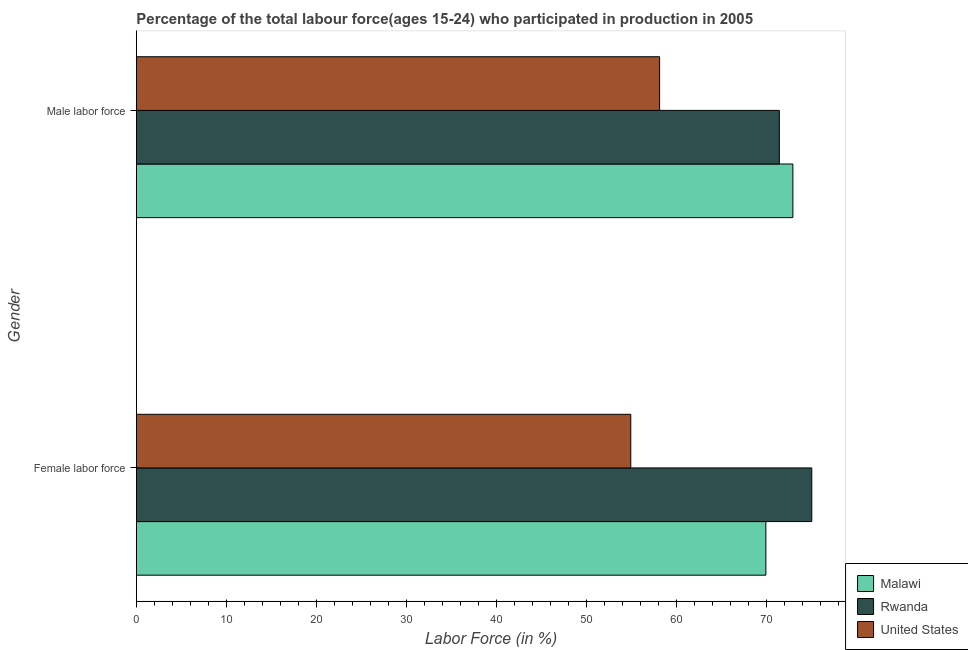How many different coloured bars are there?
Give a very brief answer. 3. How many groups of bars are there?
Offer a very short reply. 2. Are the number of bars on each tick of the Y-axis equal?
Make the answer very short. Yes. How many bars are there on the 2nd tick from the top?
Your answer should be compact. 3. What is the label of the 2nd group of bars from the top?
Your answer should be compact. Female labor force. What is the percentage of female labor force in United States?
Keep it short and to the point. 54.9. Across all countries, what is the minimum percentage of female labor force?
Your answer should be compact. 54.9. In which country was the percentage of female labor force maximum?
Your answer should be compact. Rwanda. In which country was the percentage of male labour force minimum?
Offer a terse response. United States. What is the total percentage of male labour force in the graph?
Your response must be concise. 202.4. What is the difference between the percentage of female labor force in United States and that in Malawi?
Your response must be concise. -15. What is the difference between the percentage of female labor force in Rwanda and the percentage of male labour force in Malawi?
Make the answer very short. 2.1. What is the average percentage of female labor force per country?
Your answer should be very brief. 66.6. What is the difference between the percentage of female labor force and percentage of male labour force in United States?
Your response must be concise. -3.2. In how many countries, is the percentage of male labour force greater than 48 %?
Keep it short and to the point. 3. What is the ratio of the percentage of male labour force in United States to that in Malawi?
Your response must be concise. 0.8. What does the 1st bar from the bottom in Female labor force represents?
Offer a very short reply. Malawi. How many bars are there?
Your response must be concise. 6. Are all the bars in the graph horizontal?
Provide a short and direct response. Yes. Does the graph contain any zero values?
Your answer should be very brief. No. How many legend labels are there?
Provide a short and direct response. 3. How are the legend labels stacked?
Make the answer very short. Vertical. What is the title of the graph?
Provide a short and direct response. Percentage of the total labour force(ages 15-24) who participated in production in 2005. What is the label or title of the X-axis?
Make the answer very short. Labor Force (in %). What is the label or title of the Y-axis?
Make the answer very short. Gender. What is the Labor Force (in %) of Malawi in Female labor force?
Offer a terse response. 69.9. What is the Labor Force (in %) of United States in Female labor force?
Give a very brief answer. 54.9. What is the Labor Force (in %) in Malawi in Male labor force?
Provide a succinct answer. 72.9. What is the Labor Force (in %) of Rwanda in Male labor force?
Offer a very short reply. 71.4. What is the Labor Force (in %) of United States in Male labor force?
Your response must be concise. 58.1. Across all Gender, what is the maximum Labor Force (in %) in Malawi?
Ensure brevity in your answer.  72.9. Across all Gender, what is the maximum Labor Force (in %) of United States?
Ensure brevity in your answer.  58.1. Across all Gender, what is the minimum Labor Force (in %) in Malawi?
Your answer should be very brief. 69.9. Across all Gender, what is the minimum Labor Force (in %) in Rwanda?
Offer a terse response. 71.4. Across all Gender, what is the minimum Labor Force (in %) in United States?
Provide a short and direct response. 54.9. What is the total Labor Force (in %) of Malawi in the graph?
Your answer should be very brief. 142.8. What is the total Labor Force (in %) of Rwanda in the graph?
Keep it short and to the point. 146.4. What is the total Labor Force (in %) of United States in the graph?
Provide a succinct answer. 113. What is the difference between the Labor Force (in %) in United States in Female labor force and that in Male labor force?
Offer a terse response. -3.2. What is the difference between the Labor Force (in %) in Rwanda in Female labor force and the Labor Force (in %) in United States in Male labor force?
Your answer should be very brief. 16.9. What is the average Labor Force (in %) of Malawi per Gender?
Provide a short and direct response. 71.4. What is the average Labor Force (in %) in Rwanda per Gender?
Your answer should be very brief. 73.2. What is the average Labor Force (in %) in United States per Gender?
Provide a succinct answer. 56.5. What is the difference between the Labor Force (in %) in Malawi and Labor Force (in %) in United States in Female labor force?
Make the answer very short. 15. What is the difference between the Labor Force (in %) of Rwanda and Labor Force (in %) of United States in Female labor force?
Your answer should be very brief. 20.1. What is the difference between the Labor Force (in %) of Malawi and Labor Force (in %) of Rwanda in Male labor force?
Provide a succinct answer. 1.5. What is the difference between the Labor Force (in %) in Malawi and Labor Force (in %) in United States in Male labor force?
Keep it short and to the point. 14.8. What is the difference between the Labor Force (in %) in Rwanda and Labor Force (in %) in United States in Male labor force?
Give a very brief answer. 13.3. What is the ratio of the Labor Force (in %) of Malawi in Female labor force to that in Male labor force?
Make the answer very short. 0.96. What is the ratio of the Labor Force (in %) of Rwanda in Female labor force to that in Male labor force?
Keep it short and to the point. 1.05. What is the ratio of the Labor Force (in %) of United States in Female labor force to that in Male labor force?
Your answer should be very brief. 0.94. What is the difference between the highest and the second highest Labor Force (in %) of Malawi?
Offer a terse response. 3. What is the difference between the highest and the lowest Labor Force (in %) in Rwanda?
Provide a short and direct response. 3.6. 